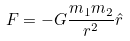<formula> <loc_0><loc_0><loc_500><loc_500>F = - G \frac { m _ { 1 } m _ { 2 } } { r ^ { 2 } } \hat { r }</formula> 